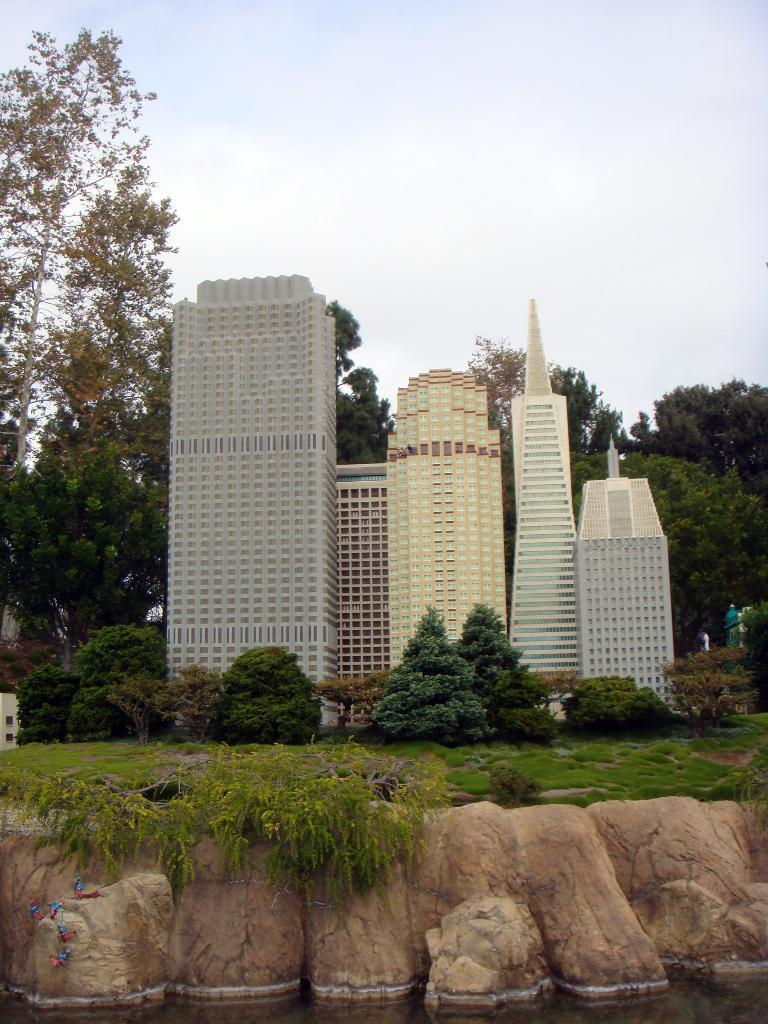What type of natural elements can be seen in the image? There are rocks, green grass, and trees visible in the image. What type of man-made structures are present in the image? There are buildings in the image. What is the body of water visible in the image? There is water visible in the image. What can be seen in the background of the image? The sky is visible in the background of the image. What type of rake is being used to create friction on the box in the image? There is no rake or box present in the image, and therefore no such activity can be observed. 